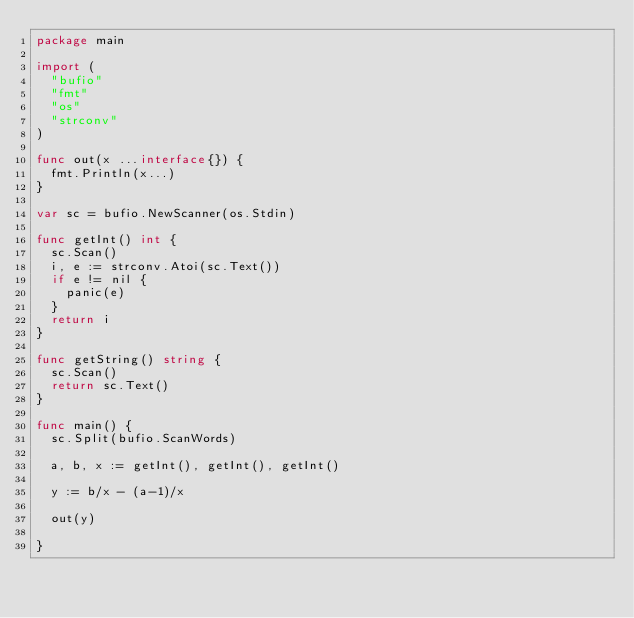<code> <loc_0><loc_0><loc_500><loc_500><_Go_>package main

import (
	"bufio"
	"fmt"
	"os"
	"strconv"
)

func out(x ...interface{}) {
	fmt.Println(x...)
}

var sc = bufio.NewScanner(os.Stdin)

func getInt() int {
	sc.Scan()
	i, e := strconv.Atoi(sc.Text())
	if e != nil {
		panic(e)
	}
	return i
}

func getString() string {
	sc.Scan()
	return sc.Text()
}

func main() {
	sc.Split(bufio.ScanWords)

	a, b, x := getInt(), getInt(), getInt()

	y := b/x - (a-1)/x

	out(y)

}
</code> 